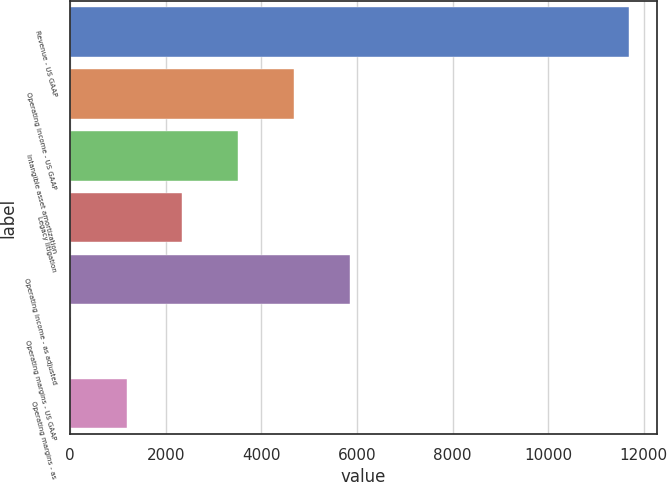Convert chart. <chart><loc_0><loc_0><loc_500><loc_500><bar_chart><fcel>Revenue - US GAAP<fcel>Operating income - US GAAP<fcel>Intangible asset amortization<fcel>Legacy litigation<fcel>Operating income - as adjusted<fcel>Operating margins - US GAAP<fcel>Operating margins - as<nl><fcel>11682<fcel>4682.28<fcel>3515.66<fcel>2349.04<fcel>5848.9<fcel>15.8<fcel>1182.42<nl></chart> 